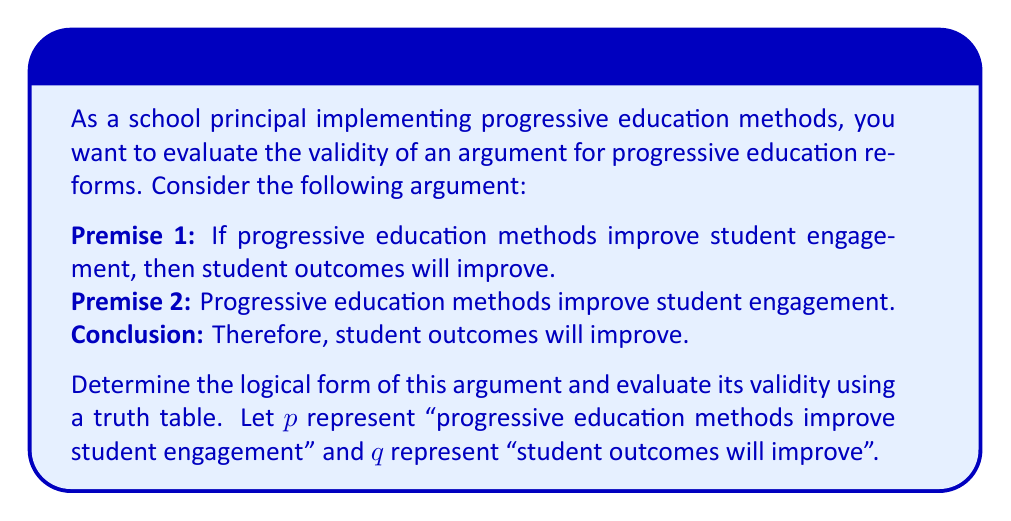Can you solve this math problem? To evaluate the validity of this argument, we'll follow these steps:

1. Identify the logical form of the argument:
   The argument has the form:
   Premise 1: $p \implies q$
   Premise 2: $p$
   Conclusion: $q$

   This is a classic form of argument known as Modus Ponens.

2. Construct a truth table:
   We'll create a truth table for the premises and conclusion:

   $$
   \begin{array}{|c|c|c|c|c|}
   \hline
   p & q & p \implies q & p & q \\
   \hline
   T & T & T & T & T \\
   T & F & F & T & F \\
   F & T & T & F & T \\
   F & F & T & F & F \\
   \hline
   \end{array}
   $$

3. Analyze the truth table:
   - The first column ($p$) represents Premise 2
   - The second column ($p \implies q$) represents Premise 1
   - The last column ($q$) represents the Conclusion

4. Check for validity:
   An argument is valid if, whenever all premises are true, the conclusion must also be true.
   In this truth table, whenever both premises are true (first row), the conclusion is also true.

5. Interpret the results:
   The argument is valid because in every case where both premises are true (first row of the truth table), the conclusion is also true. This means that if we accept the premises as true, we must logically accept the conclusion as true.
Answer: Valid argument (Modus Ponens) 